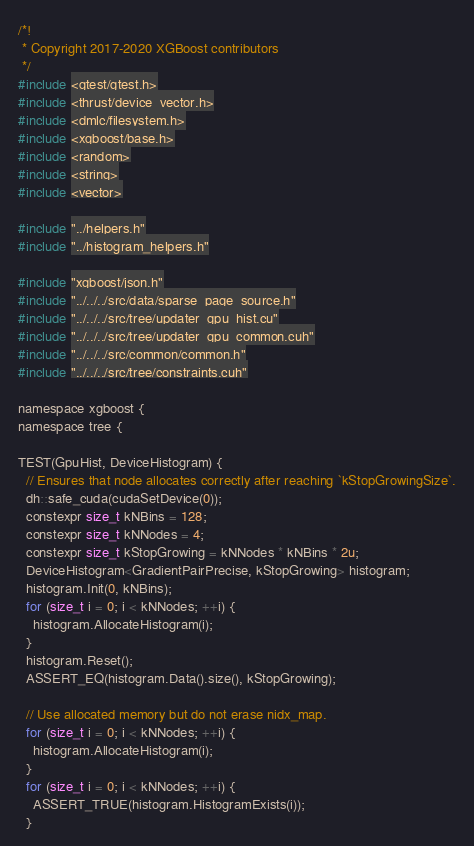<code> <loc_0><loc_0><loc_500><loc_500><_Cuda_>/*!
 * Copyright 2017-2020 XGBoost contributors
 */
#include <gtest/gtest.h>
#include <thrust/device_vector.h>
#include <dmlc/filesystem.h>
#include <xgboost/base.h>
#include <random>
#include <string>
#include <vector>

#include "../helpers.h"
#include "../histogram_helpers.h"

#include "xgboost/json.h"
#include "../../../src/data/sparse_page_source.h"
#include "../../../src/tree/updater_gpu_hist.cu"
#include "../../../src/tree/updater_gpu_common.cuh"
#include "../../../src/common/common.h"
#include "../../../src/tree/constraints.cuh"

namespace xgboost {
namespace tree {

TEST(GpuHist, DeviceHistogram) {
  // Ensures that node allocates correctly after reaching `kStopGrowingSize`.
  dh::safe_cuda(cudaSetDevice(0));
  constexpr size_t kNBins = 128;
  constexpr size_t kNNodes = 4;
  constexpr size_t kStopGrowing = kNNodes * kNBins * 2u;
  DeviceHistogram<GradientPairPrecise, kStopGrowing> histogram;
  histogram.Init(0, kNBins);
  for (size_t i = 0; i < kNNodes; ++i) {
    histogram.AllocateHistogram(i);
  }
  histogram.Reset();
  ASSERT_EQ(histogram.Data().size(), kStopGrowing);

  // Use allocated memory but do not erase nidx_map.
  for (size_t i = 0; i < kNNodes; ++i) {
    histogram.AllocateHistogram(i);
  }
  for (size_t i = 0; i < kNNodes; ++i) {
    ASSERT_TRUE(histogram.HistogramExists(i));
  }
</code> 